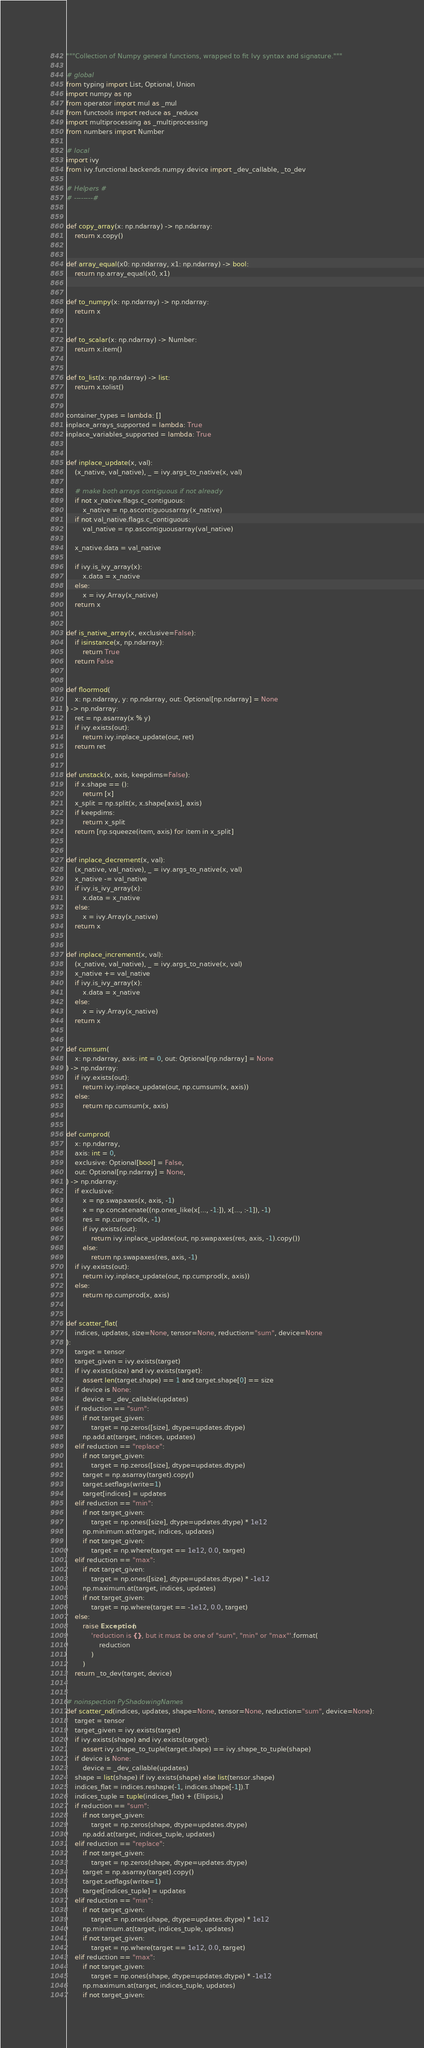Convert code to text. <code><loc_0><loc_0><loc_500><loc_500><_Python_>"""Collection of Numpy general functions, wrapped to fit Ivy syntax and signature."""

# global
from typing import List, Optional, Union
import numpy as np
from operator import mul as _mul
from functools import reduce as _reduce
import multiprocessing as _multiprocessing
from numbers import Number

# local
import ivy
from ivy.functional.backends.numpy.device import _dev_callable, _to_dev

# Helpers #
# --------#


def copy_array(x: np.ndarray) -> np.ndarray:
    return x.copy()


def array_equal(x0: np.ndarray, x1: np.ndarray) -> bool:
    return np.array_equal(x0, x1)


def to_numpy(x: np.ndarray) -> np.ndarray:
    return x


def to_scalar(x: np.ndarray) -> Number:
    return x.item()


def to_list(x: np.ndarray) -> list:
    return x.tolist()


container_types = lambda: []
inplace_arrays_supported = lambda: True
inplace_variables_supported = lambda: True


def inplace_update(x, val):
    (x_native, val_native), _ = ivy.args_to_native(x, val)

    # make both arrays contiguous if not already
    if not x_native.flags.c_contiguous:
        x_native = np.ascontiguousarray(x_native)
    if not val_native.flags.c_contiguous:
        val_native = np.ascontiguousarray(val_native)

    x_native.data = val_native

    if ivy.is_ivy_array(x):
        x.data = x_native
    else:
        x = ivy.Array(x_native)
    return x


def is_native_array(x, exclusive=False):
    if isinstance(x, np.ndarray):
        return True
    return False


def floormod(
    x: np.ndarray, y: np.ndarray, out: Optional[np.ndarray] = None
) -> np.ndarray:
    ret = np.asarray(x % y)
    if ivy.exists(out):
        return ivy.inplace_update(out, ret)
    return ret


def unstack(x, axis, keepdims=False):
    if x.shape == ():
        return [x]
    x_split = np.split(x, x.shape[axis], axis)
    if keepdims:
        return x_split
    return [np.squeeze(item, axis) for item in x_split]


def inplace_decrement(x, val):
    (x_native, val_native), _ = ivy.args_to_native(x, val)
    x_native -= val_native
    if ivy.is_ivy_array(x):
        x.data = x_native
    else:
        x = ivy.Array(x_native)
    return x


def inplace_increment(x, val):
    (x_native, val_native), _ = ivy.args_to_native(x, val)
    x_native += val_native
    if ivy.is_ivy_array(x):
        x.data = x_native
    else:
        x = ivy.Array(x_native)
    return x


def cumsum(
    x: np.ndarray, axis: int = 0, out: Optional[np.ndarray] = None
) -> np.ndarray:
    if ivy.exists(out):
        return ivy.inplace_update(out, np.cumsum(x, axis))
    else:
        return np.cumsum(x, axis)


def cumprod(
    x: np.ndarray,
    axis: int = 0,
    exclusive: Optional[bool] = False,
    out: Optional[np.ndarray] = None,
) -> np.ndarray:
    if exclusive:
        x = np.swapaxes(x, axis, -1)
        x = np.concatenate((np.ones_like(x[..., -1:]), x[..., :-1]), -1)
        res = np.cumprod(x, -1)
        if ivy.exists(out):
            return ivy.inplace_update(out, np.swapaxes(res, axis, -1).copy())
        else:
            return np.swapaxes(res, axis, -1)
    if ivy.exists(out):
        return ivy.inplace_update(out, np.cumprod(x, axis))
    else:
        return np.cumprod(x, axis)


def scatter_flat(
    indices, updates, size=None, tensor=None, reduction="sum", device=None
):
    target = tensor
    target_given = ivy.exists(target)
    if ivy.exists(size) and ivy.exists(target):
        assert len(target.shape) == 1 and target.shape[0] == size
    if device is None:
        device = _dev_callable(updates)
    if reduction == "sum":
        if not target_given:
            target = np.zeros([size], dtype=updates.dtype)
        np.add.at(target, indices, updates)
    elif reduction == "replace":
        if not target_given:
            target = np.zeros([size], dtype=updates.dtype)
        target = np.asarray(target).copy()
        target.setflags(write=1)
        target[indices] = updates
    elif reduction == "min":
        if not target_given:
            target = np.ones([size], dtype=updates.dtype) * 1e12
        np.minimum.at(target, indices, updates)
        if not target_given:
            target = np.where(target == 1e12, 0.0, target)
    elif reduction == "max":
        if not target_given:
            target = np.ones([size], dtype=updates.dtype) * -1e12
        np.maximum.at(target, indices, updates)
        if not target_given:
            target = np.where(target == -1e12, 0.0, target)
    else:
        raise Exception(
            'reduction is {}, but it must be one of "sum", "min" or "max"'.format(
                reduction
            )
        )
    return _to_dev(target, device)


# noinspection PyShadowingNames
def scatter_nd(indices, updates, shape=None, tensor=None, reduction="sum", device=None):
    target = tensor
    target_given = ivy.exists(target)
    if ivy.exists(shape) and ivy.exists(target):
        assert ivy.shape_to_tuple(target.shape) == ivy.shape_to_tuple(shape)
    if device is None:
        device = _dev_callable(updates)
    shape = list(shape) if ivy.exists(shape) else list(tensor.shape)
    indices_flat = indices.reshape(-1, indices.shape[-1]).T
    indices_tuple = tuple(indices_flat) + (Ellipsis,)
    if reduction == "sum":
        if not target_given:
            target = np.zeros(shape, dtype=updates.dtype)
        np.add.at(target, indices_tuple, updates)
    elif reduction == "replace":
        if not target_given:
            target = np.zeros(shape, dtype=updates.dtype)
        target = np.asarray(target).copy()
        target.setflags(write=1)
        target[indices_tuple] = updates
    elif reduction == "min":
        if not target_given:
            target = np.ones(shape, dtype=updates.dtype) * 1e12
        np.minimum.at(target, indices_tuple, updates)
        if not target_given:
            target = np.where(target == 1e12, 0.0, target)
    elif reduction == "max":
        if not target_given:
            target = np.ones(shape, dtype=updates.dtype) * -1e12
        np.maximum.at(target, indices_tuple, updates)
        if not target_given:</code> 